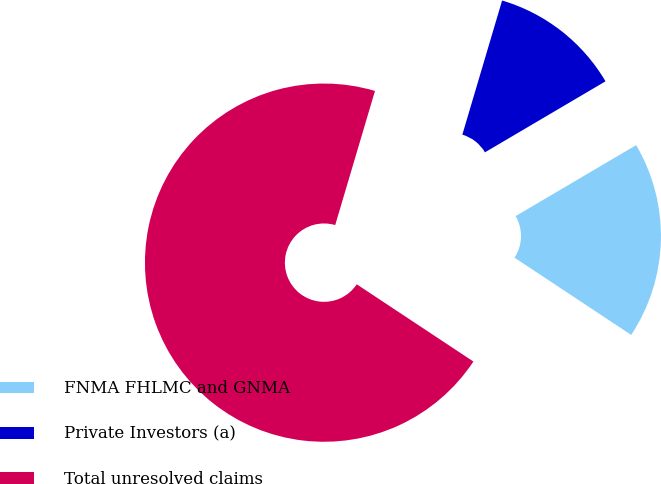<chart> <loc_0><loc_0><loc_500><loc_500><pie_chart><fcel>FNMA FHLMC and GNMA<fcel>Private Investors (a)<fcel>Total unresolved claims<nl><fcel>17.78%<fcel>11.94%<fcel>70.28%<nl></chart> 